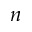Convert formula to latex. <formula><loc_0><loc_0><loc_500><loc_500>n</formula> 